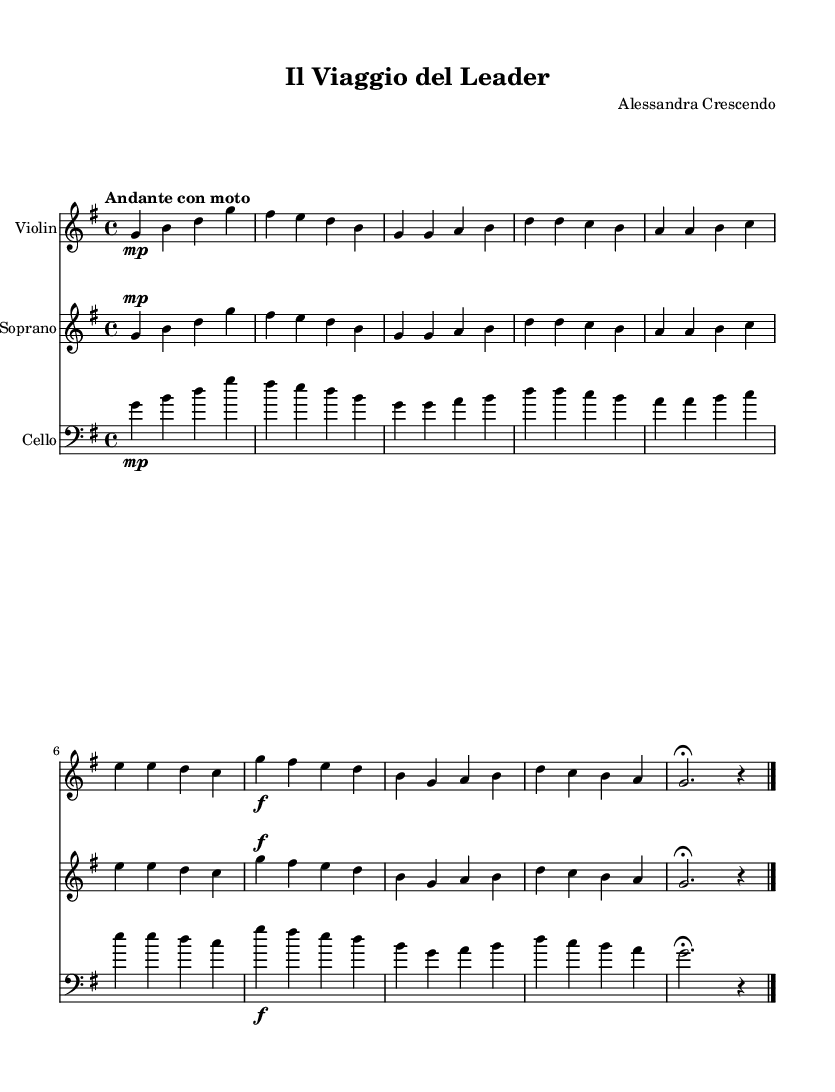What is the key signature of this music? The key signature is G major, which has one sharp (F#). This is indicated on the left side of the staff at the beginning of the piece.
Answer: G major What is the time signature of this music? The time signature is 4/4, which means there are four beats in each measure and the quarter note gets one beat. This is indicated in the beginning of the music under the clef.
Answer: 4/4 What is the tempo marking in this piece? The tempo marking is "Andante con moto," which suggests a moderately slow tempo with some movement. This is usually indicated near the top of the score alongside the key signature.
Answer: Andante con moto What instrument plays the lower staff? The lower staff is labeled as the "Cello," which indicates that this part is for the cello instrument. This can be identified by the instrument name written at the beginning of the lower staff.
Answer: Cello How many measures are in the soprano part? The soprano part consists of 8 measures. This can be determined by counting the segments separated by the vertical lines (bar lines) in the soprano staff.
Answer: 8 measures What musical form does this opera piece reflect in terms of personal growth and leadership? The piece reflects a theme of encouragement and aspiration, as indicated by the uplifting lyrics and the dynamic markings. The lyrics describe support and growth, which aligns with the concepts of leadership and personal growth.
Answer: Encouragement 